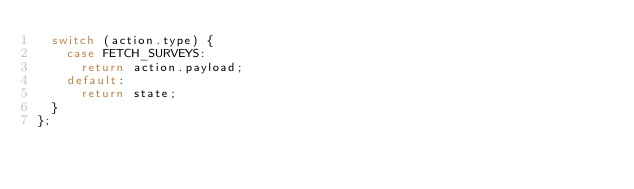<code> <loc_0><loc_0><loc_500><loc_500><_JavaScript_>  switch (action.type) {
    case FETCH_SURVEYS:
      return action.payload;
    default:
      return state;
  }
};
</code> 